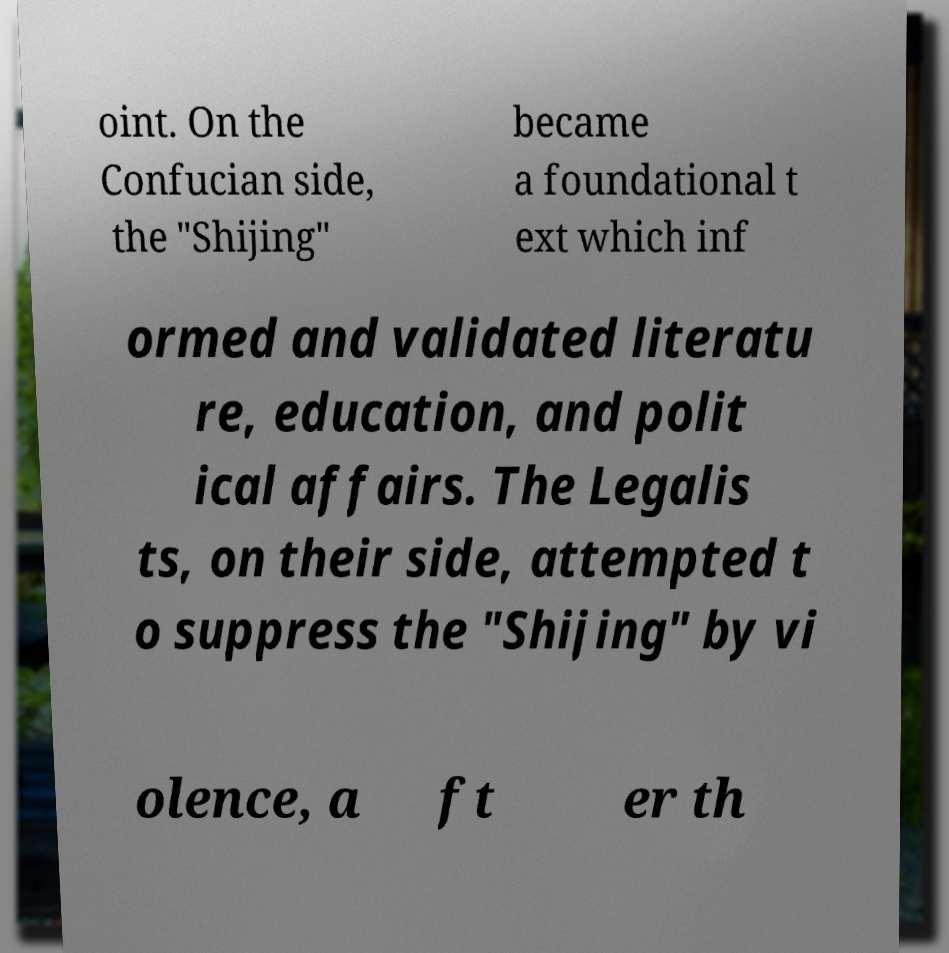There's text embedded in this image that I need extracted. Can you transcribe it verbatim? oint. On the Confucian side, the "Shijing" became a foundational t ext which inf ormed and validated literatu re, education, and polit ical affairs. The Legalis ts, on their side, attempted t o suppress the "Shijing" by vi olence, a ft er th 